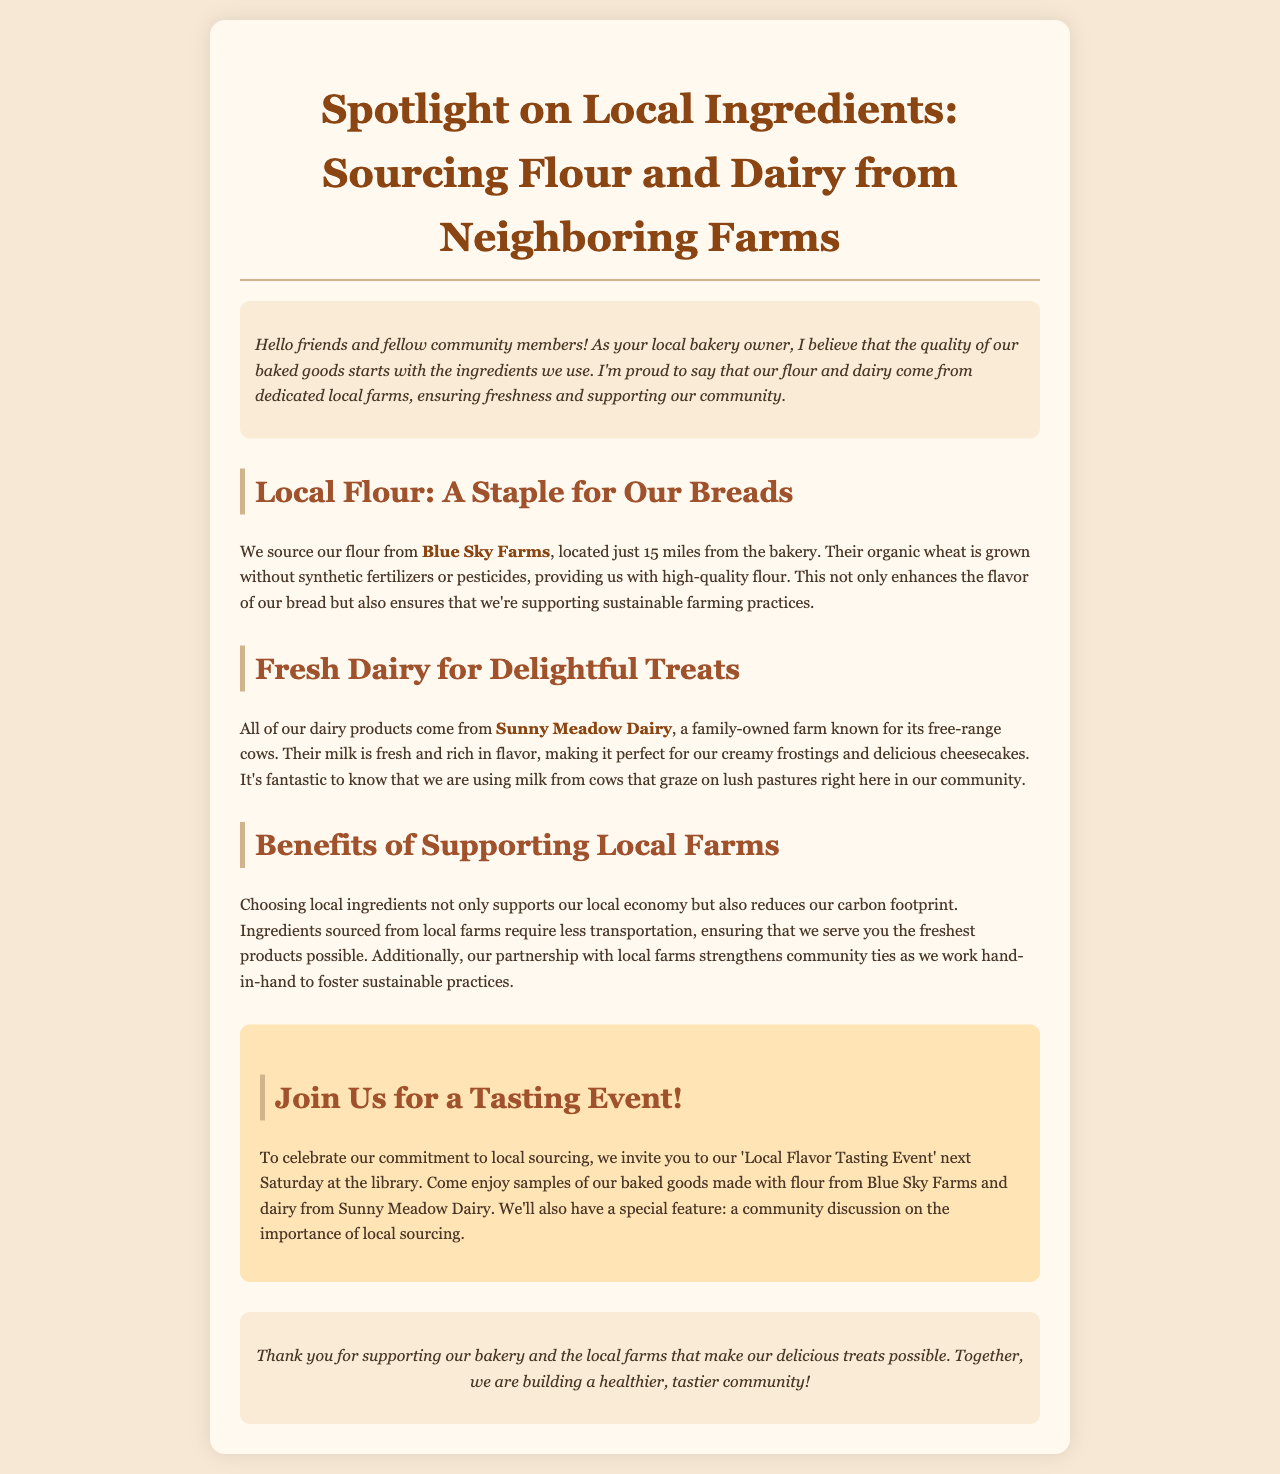What is the name of the flour supplier? The document states that the flour is sourced from Blue Sky Farms.
Answer: Blue Sky Farms How far is Blue Sky Farms from the bakery? The document mentions that Blue Sky Farms is located 15 miles from the bakery.
Answer: 15 miles What type of farming practices does Blue Sky Farms use? The document indicates that Blue Sky Farms grows their organic wheat without synthetic fertilizers or pesticides.
Answer: Organic What dairy farm supplies the bakery? The document states that all dairy products come from Sunny Meadow Dairy.
Answer: Sunny Meadow Dairy What is a key feature of Sunny Meadow Dairy's cows? According to the document, Sunny Meadow Dairy is known for its free-range cows.
Answer: Free-range What event is being held to celebrate local sourcing? The document mentions a 'Local Flavor Tasting Event' taking place next Saturday at the library.
Answer: Local Flavor Tasting Event Why is local sourcing beneficial according to the document? The document explains that local sourcing supports the local economy and reduces carbon footprint.
Answer: Supports local economy What will be discussed at the tasting event? The document mentions a community discussion on the importance of local sourcing will be featured at the event.
Answer: Community discussion on local sourcing What type of newsletter is this document? The document is a newsletter focused on local ingredients in baking.
Answer: Newsletter 